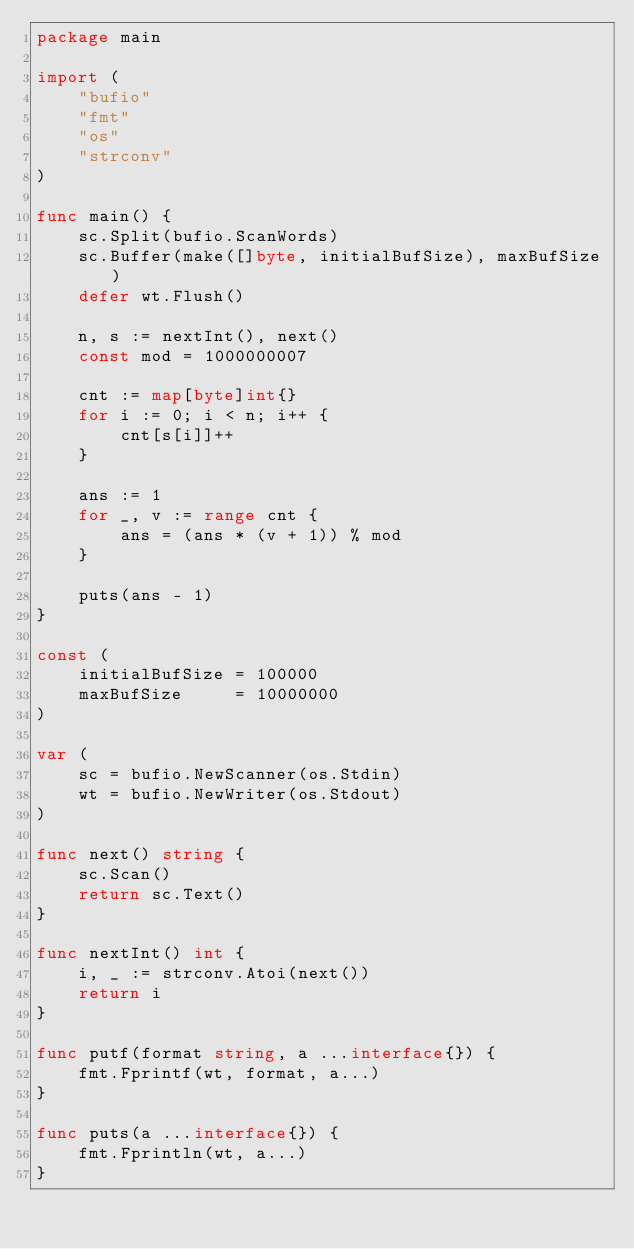<code> <loc_0><loc_0><loc_500><loc_500><_Go_>package main

import (
	"bufio"
	"fmt"
	"os"
	"strconv"
)

func main() {
	sc.Split(bufio.ScanWords)
	sc.Buffer(make([]byte, initialBufSize), maxBufSize)
	defer wt.Flush()

	n, s := nextInt(), next()
	const mod = 1000000007

	cnt := map[byte]int{}
	for i := 0; i < n; i++ {
		cnt[s[i]]++
	}

	ans := 1
	for _, v := range cnt {
		ans = (ans * (v + 1)) % mod
	}

	puts(ans - 1)
}

const (
	initialBufSize = 100000
	maxBufSize     = 10000000
)

var (
	sc = bufio.NewScanner(os.Stdin)
	wt = bufio.NewWriter(os.Stdout)
)

func next() string {
	sc.Scan()
	return sc.Text()
}

func nextInt() int {
	i, _ := strconv.Atoi(next())
	return i
}

func putf(format string, a ...interface{}) {
	fmt.Fprintf(wt, format, a...)
}

func puts(a ...interface{}) {
	fmt.Fprintln(wt, a...)
}
</code> 